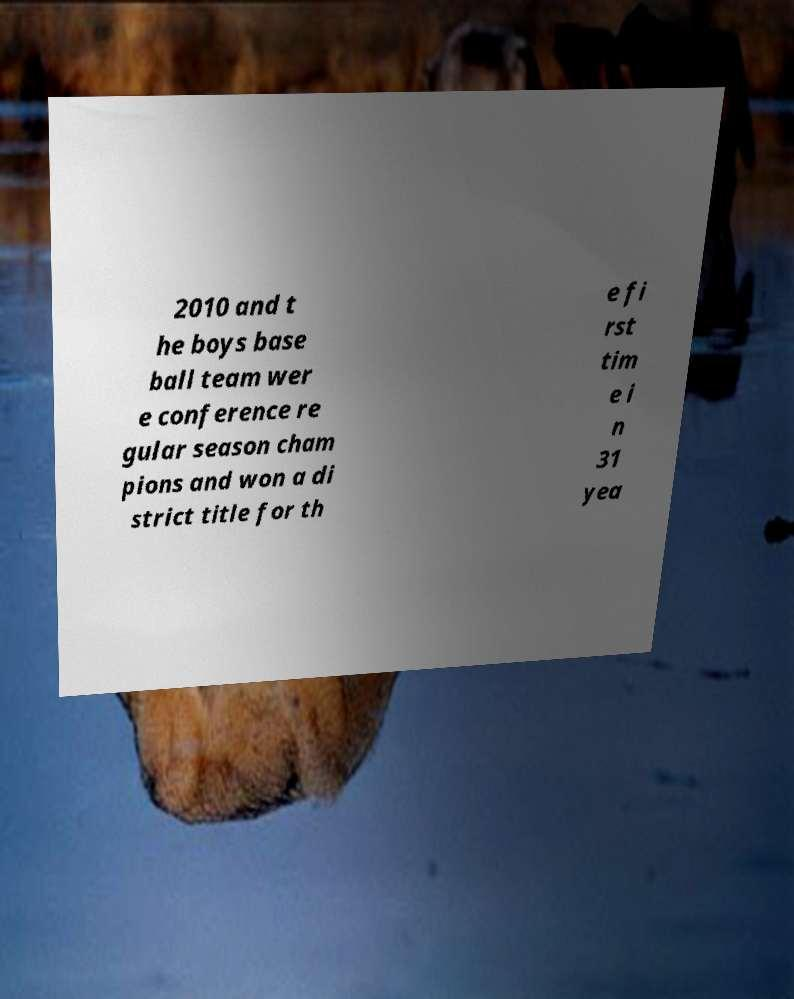I need the written content from this picture converted into text. Can you do that? 2010 and t he boys base ball team wer e conference re gular season cham pions and won a di strict title for th e fi rst tim e i n 31 yea 